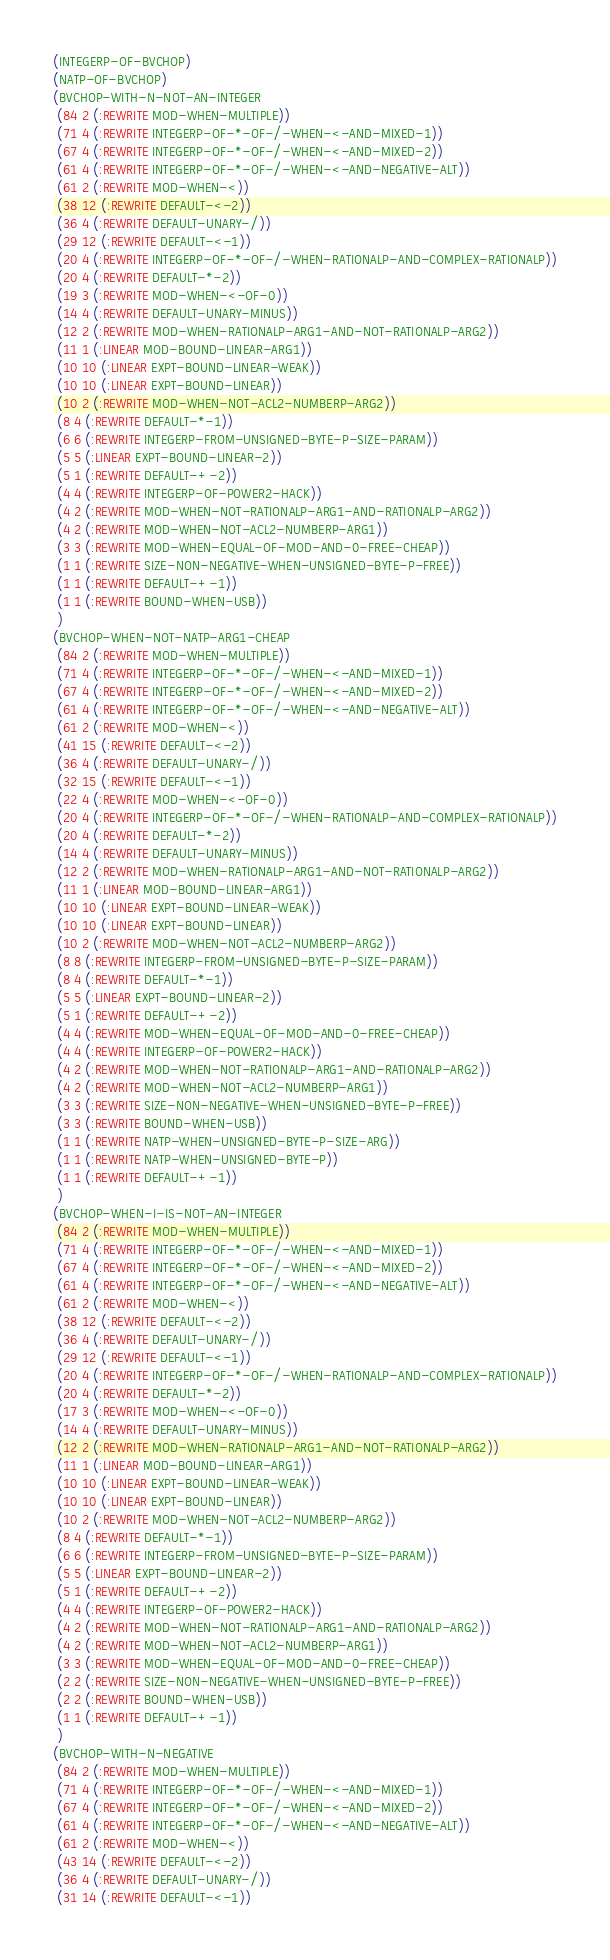<code> <loc_0><loc_0><loc_500><loc_500><_Lisp_>(INTEGERP-OF-BVCHOP)
(NATP-OF-BVCHOP)
(BVCHOP-WITH-N-NOT-AN-INTEGER
 (84 2 (:REWRITE MOD-WHEN-MULTIPLE))
 (71 4 (:REWRITE INTEGERP-OF-*-OF-/-WHEN-<-AND-MIXED-1))
 (67 4 (:REWRITE INTEGERP-OF-*-OF-/-WHEN-<-AND-MIXED-2))
 (61 4 (:REWRITE INTEGERP-OF-*-OF-/-WHEN-<-AND-NEGATIVE-ALT))
 (61 2 (:REWRITE MOD-WHEN-<))
 (38 12 (:REWRITE DEFAULT-<-2))
 (36 4 (:REWRITE DEFAULT-UNARY-/))
 (29 12 (:REWRITE DEFAULT-<-1))
 (20 4 (:REWRITE INTEGERP-OF-*-OF-/-WHEN-RATIONALP-AND-COMPLEX-RATIONALP))
 (20 4 (:REWRITE DEFAULT-*-2))
 (19 3 (:REWRITE MOD-WHEN-<-OF-0))
 (14 4 (:REWRITE DEFAULT-UNARY-MINUS))
 (12 2 (:REWRITE MOD-WHEN-RATIONALP-ARG1-AND-NOT-RATIONALP-ARG2))
 (11 1 (:LINEAR MOD-BOUND-LINEAR-ARG1))
 (10 10 (:LINEAR EXPT-BOUND-LINEAR-WEAK))
 (10 10 (:LINEAR EXPT-BOUND-LINEAR))
 (10 2 (:REWRITE MOD-WHEN-NOT-ACL2-NUMBERP-ARG2))
 (8 4 (:REWRITE DEFAULT-*-1))
 (6 6 (:REWRITE INTEGERP-FROM-UNSIGNED-BYTE-P-SIZE-PARAM))
 (5 5 (:LINEAR EXPT-BOUND-LINEAR-2))
 (5 1 (:REWRITE DEFAULT-+-2))
 (4 4 (:REWRITE INTEGERP-OF-POWER2-HACK))
 (4 2 (:REWRITE MOD-WHEN-NOT-RATIONALP-ARG1-AND-RATIONALP-ARG2))
 (4 2 (:REWRITE MOD-WHEN-NOT-ACL2-NUMBERP-ARG1))
 (3 3 (:REWRITE MOD-WHEN-EQUAL-OF-MOD-AND-0-FREE-CHEAP))
 (1 1 (:REWRITE SIZE-NON-NEGATIVE-WHEN-UNSIGNED-BYTE-P-FREE))
 (1 1 (:REWRITE DEFAULT-+-1))
 (1 1 (:REWRITE BOUND-WHEN-USB))
 )
(BVCHOP-WHEN-NOT-NATP-ARG1-CHEAP
 (84 2 (:REWRITE MOD-WHEN-MULTIPLE))
 (71 4 (:REWRITE INTEGERP-OF-*-OF-/-WHEN-<-AND-MIXED-1))
 (67 4 (:REWRITE INTEGERP-OF-*-OF-/-WHEN-<-AND-MIXED-2))
 (61 4 (:REWRITE INTEGERP-OF-*-OF-/-WHEN-<-AND-NEGATIVE-ALT))
 (61 2 (:REWRITE MOD-WHEN-<))
 (41 15 (:REWRITE DEFAULT-<-2))
 (36 4 (:REWRITE DEFAULT-UNARY-/))
 (32 15 (:REWRITE DEFAULT-<-1))
 (22 4 (:REWRITE MOD-WHEN-<-OF-0))
 (20 4 (:REWRITE INTEGERP-OF-*-OF-/-WHEN-RATIONALP-AND-COMPLEX-RATIONALP))
 (20 4 (:REWRITE DEFAULT-*-2))
 (14 4 (:REWRITE DEFAULT-UNARY-MINUS))
 (12 2 (:REWRITE MOD-WHEN-RATIONALP-ARG1-AND-NOT-RATIONALP-ARG2))
 (11 1 (:LINEAR MOD-BOUND-LINEAR-ARG1))
 (10 10 (:LINEAR EXPT-BOUND-LINEAR-WEAK))
 (10 10 (:LINEAR EXPT-BOUND-LINEAR))
 (10 2 (:REWRITE MOD-WHEN-NOT-ACL2-NUMBERP-ARG2))
 (8 8 (:REWRITE INTEGERP-FROM-UNSIGNED-BYTE-P-SIZE-PARAM))
 (8 4 (:REWRITE DEFAULT-*-1))
 (5 5 (:LINEAR EXPT-BOUND-LINEAR-2))
 (5 1 (:REWRITE DEFAULT-+-2))
 (4 4 (:REWRITE MOD-WHEN-EQUAL-OF-MOD-AND-0-FREE-CHEAP))
 (4 4 (:REWRITE INTEGERP-OF-POWER2-HACK))
 (4 2 (:REWRITE MOD-WHEN-NOT-RATIONALP-ARG1-AND-RATIONALP-ARG2))
 (4 2 (:REWRITE MOD-WHEN-NOT-ACL2-NUMBERP-ARG1))
 (3 3 (:REWRITE SIZE-NON-NEGATIVE-WHEN-UNSIGNED-BYTE-P-FREE))
 (3 3 (:REWRITE BOUND-WHEN-USB))
 (1 1 (:REWRITE NATP-WHEN-UNSIGNED-BYTE-P-SIZE-ARG))
 (1 1 (:REWRITE NATP-WHEN-UNSIGNED-BYTE-P))
 (1 1 (:REWRITE DEFAULT-+-1))
 )
(BVCHOP-WHEN-I-IS-NOT-AN-INTEGER
 (84 2 (:REWRITE MOD-WHEN-MULTIPLE))
 (71 4 (:REWRITE INTEGERP-OF-*-OF-/-WHEN-<-AND-MIXED-1))
 (67 4 (:REWRITE INTEGERP-OF-*-OF-/-WHEN-<-AND-MIXED-2))
 (61 4 (:REWRITE INTEGERP-OF-*-OF-/-WHEN-<-AND-NEGATIVE-ALT))
 (61 2 (:REWRITE MOD-WHEN-<))
 (38 12 (:REWRITE DEFAULT-<-2))
 (36 4 (:REWRITE DEFAULT-UNARY-/))
 (29 12 (:REWRITE DEFAULT-<-1))
 (20 4 (:REWRITE INTEGERP-OF-*-OF-/-WHEN-RATIONALP-AND-COMPLEX-RATIONALP))
 (20 4 (:REWRITE DEFAULT-*-2))
 (17 3 (:REWRITE MOD-WHEN-<-OF-0))
 (14 4 (:REWRITE DEFAULT-UNARY-MINUS))
 (12 2 (:REWRITE MOD-WHEN-RATIONALP-ARG1-AND-NOT-RATIONALP-ARG2))
 (11 1 (:LINEAR MOD-BOUND-LINEAR-ARG1))
 (10 10 (:LINEAR EXPT-BOUND-LINEAR-WEAK))
 (10 10 (:LINEAR EXPT-BOUND-LINEAR))
 (10 2 (:REWRITE MOD-WHEN-NOT-ACL2-NUMBERP-ARG2))
 (8 4 (:REWRITE DEFAULT-*-1))
 (6 6 (:REWRITE INTEGERP-FROM-UNSIGNED-BYTE-P-SIZE-PARAM))
 (5 5 (:LINEAR EXPT-BOUND-LINEAR-2))
 (5 1 (:REWRITE DEFAULT-+-2))
 (4 4 (:REWRITE INTEGERP-OF-POWER2-HACK))
 (4 2 (:REWRITE MOD-WHEN-NOT-RATIONALP-ARG1-AND-RATIONALP-ARG2))
 (4 2 (:REWRITE MOD-WHEN-NOT-ACL2-NUMBERP-ARG1))
 (3 3 (:REWRITE MOD-WHEN-EQUAL-OF-MOD-AND-0-FREE-CHEAP))
 (2 2 (:REWRITE SIZE-NON-NEGATIVE-WHEN-UNSIGNED-BYTE-P-FREE))
 (2 2 (:REWRITE BOUND-WHEN-USB))
 (1 1 (:REWRITE DEFAULT-+-1))
 )
(BVCHOP-WITH-N-NEGATIVE
 (84 2 (:REWRITE MOD-WHEN-MULTIPLE))
 (71 4 (:REWRITE INTEGERP-OF-*-OF-/-WHEN-<-AND-MIXED-1))
 (67 4 (:REWRITE INTEGERP-OF-*-OF-/-WHEN-<-AND-MIXED-2))
 (61 4 (:REWRITE INTEGERP-OF-*-OF-/-WHEN-<-AND-NEGATIVE-ALT))
 (61 2 (:REWRITE MOD-WHEN-<))
 (43 14 (:REWRITE DEFAULT-<-2))
 (36 4 (:REWRITE DEFAULT-UNARY-/))
 (31 14 (:REWRITE DEFAULT-<-1))</code> 